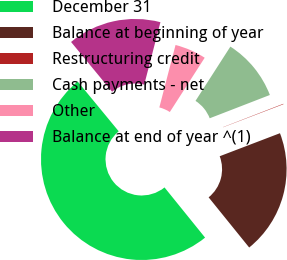Convert chart. <chart><loc_0><loc_0><loc_500><loc_500><pie_chart><fcel>December 31<fcel>Balance at beginning of year<fcel>Restructuring credit<fcel>Cash payments - net<fcel>Other<fcel>Balance at end of year ^(1)<nl><fcel>49.85%<fcel>19.99%<fcel>0.07%<fcel>10.03%<fcel>5.05%<fcel>15.01%<nl></chart> 